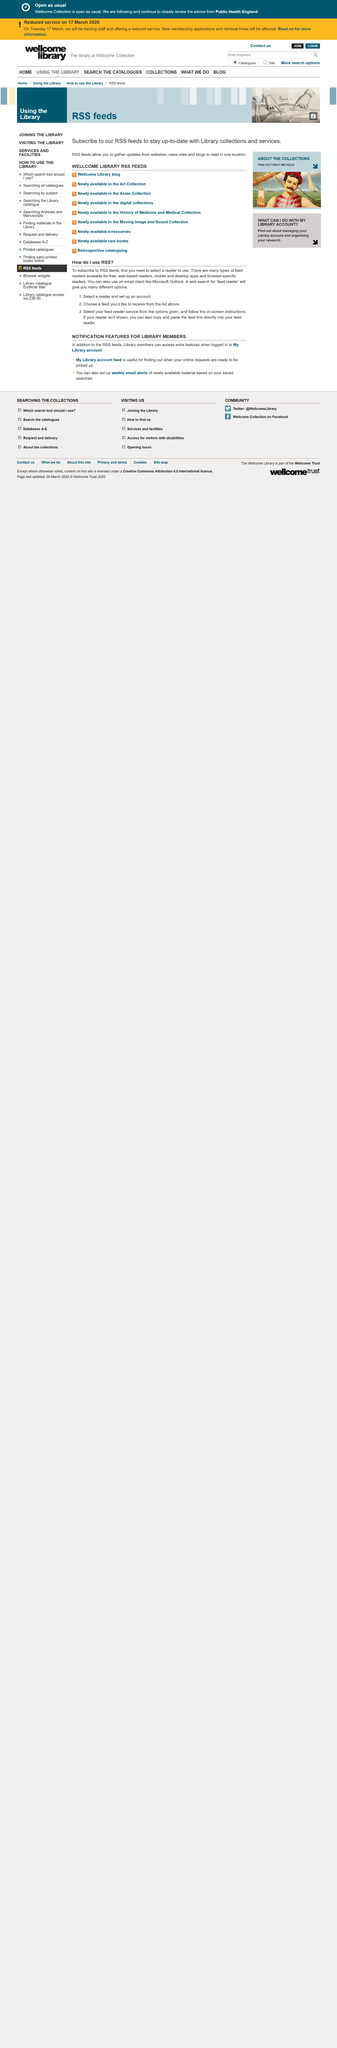Give some essential details in this illustration. If the reader is not displayed, what should I do? If your reader is not shown, you can also copy and paste the feed link directly into your feed reader. There are several types of free feed readers available, including web-based readers, mobile and desktop apps, and browser-specific readers. To subscribe to RSS feeds, you need to select a reader to use. 